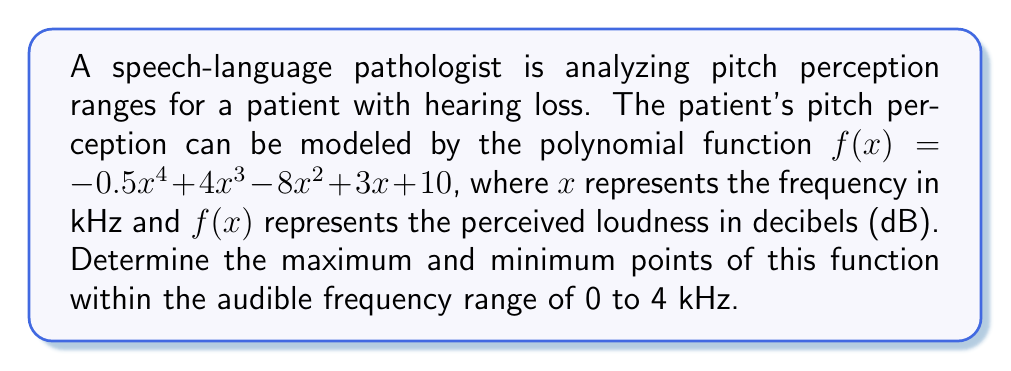Help me with this question. To find the maximum and minimum points, we need to follow these steps:

1) Find the derivative of the function:
   $f'(x) = -2x^3 + 12x^2 - 16x + 3$

2) Set the derivative equal to zero and solve for x:
   $-2x^3 + 12x^2 - 16x + 3 = 0$

3) This cubic equation can be factored as:
   $(x - 1)(2x^2 - 10x + 3) = 0$

4) Solve the resulting equations:
   $x = 1$ or $2x^2 - 10x + 3 = 0$

5) Using the quadratic formula for $2x^2 - 10x + 3 = 0$:
   $x = \frac{10 \pm \sqrt{100 - 24}}{4} = \frac{10 \pm \sqrt{76}}{4}$

6) This gives us three critical points:
   $x_1 = 1$
   $x_2 = \frac{10 + \sqrt{76}}{4} \approx 4.68$
   $x_3 = \frac{10 - \sqrt{76}}{4} \approx 0.32$

7) Since we're only interested in the range 0 to 4 kHz, we'll only consider $x_1$ and $x_3$.

8) To determine if these points are maxima or minima, we can use the second derivative test:
   $f''(x) = -6x^2 + 24x - 16$

9) Evaluate $f''(x)$ at $x_1$ and $x_3$:
   $f''(1) = 2 > 0$, so $x = 1$ is a local minimum
   $f''(0.32) \approx -11.54 < 0$, so $x = 0.32$ is a local maximum

10) Calculate the function values at these points:
    $f(0.32) \approx 10.31$ dB
    $f(1) = 8.5$ dB

Therefore, within the range of 0 to 4 kHz:
- The maximum point occurs at approximately (0.32 kHz, 10.31 dB)
- The minimum point occurs at (1 kHz, 8.5 dB)
Answer: Maximum: (0.32 kHz, 10.31 dB); Minimum: (1 kHz, 8.5 dB) 